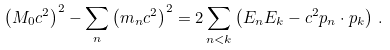Convert formula to latex. <formula><loc_0><loc_0><loc_500><loc_500>\left ( M _ { 0 } c ^ { 2 } \right ) ^ { 2 } - \sum _ { n } \left ( m _ { n } c ^ { 2 } \right ) ^ { 2 } = 2 \sum _ { n < k } \left ( E _ { n } E _ { k } - c ^ { 2 } p _ { n } \cdot p _ { k } \right ) \, .</formula> 